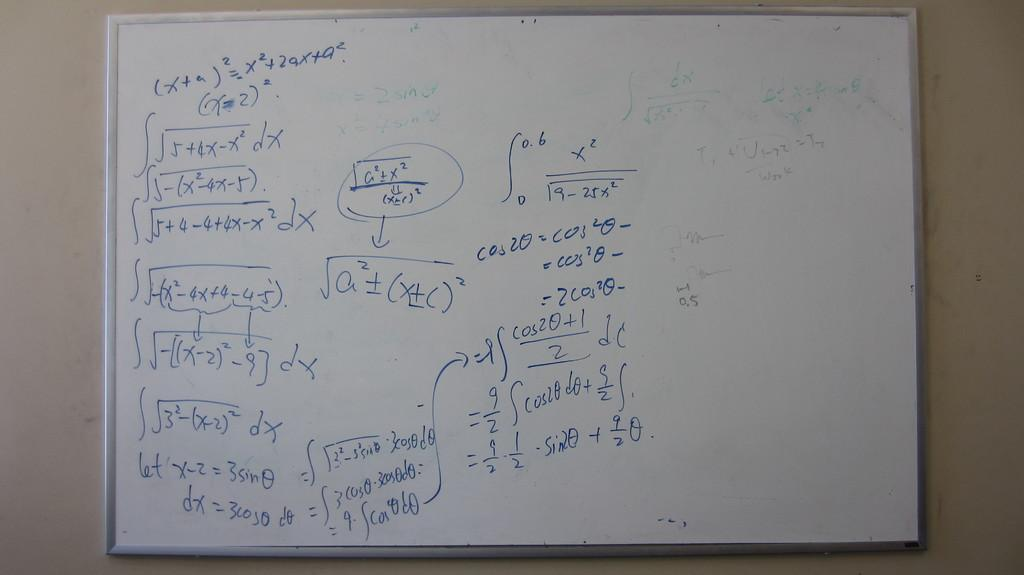<image>
Write a terse but informative summary of the picture. A white board with a series of mathematical equations on them. 